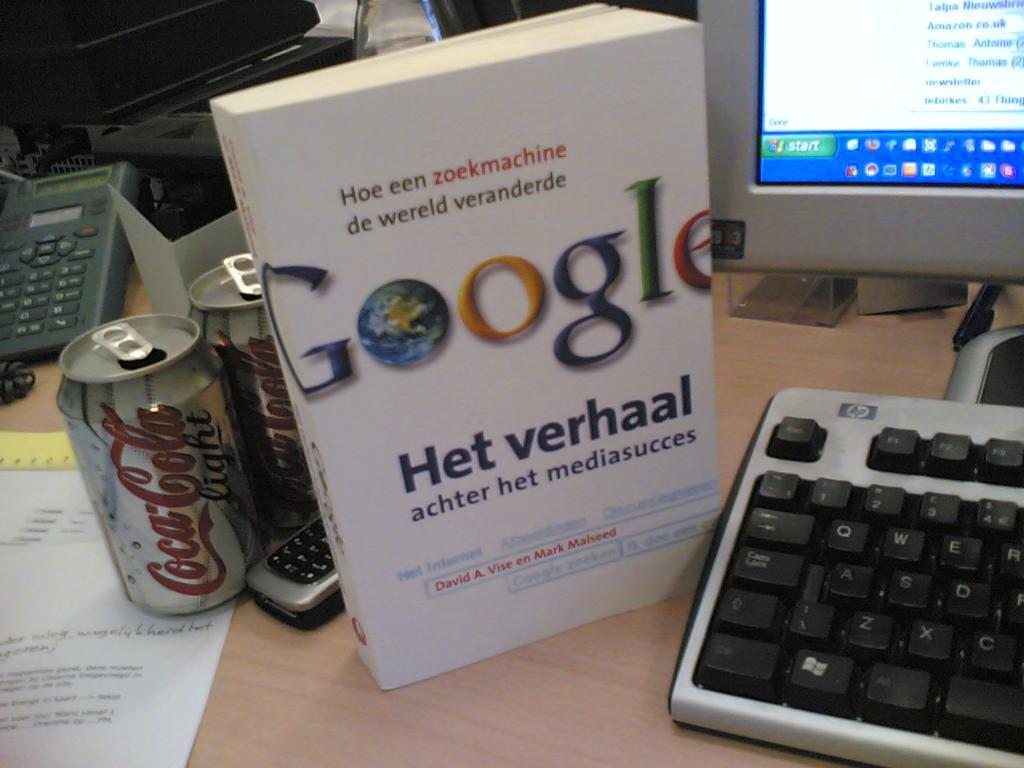What internet search engine in written on the book?
Provide a short and direct response. Google. The google het verhall is amazon brand?
Your answer should be very brief. No. 